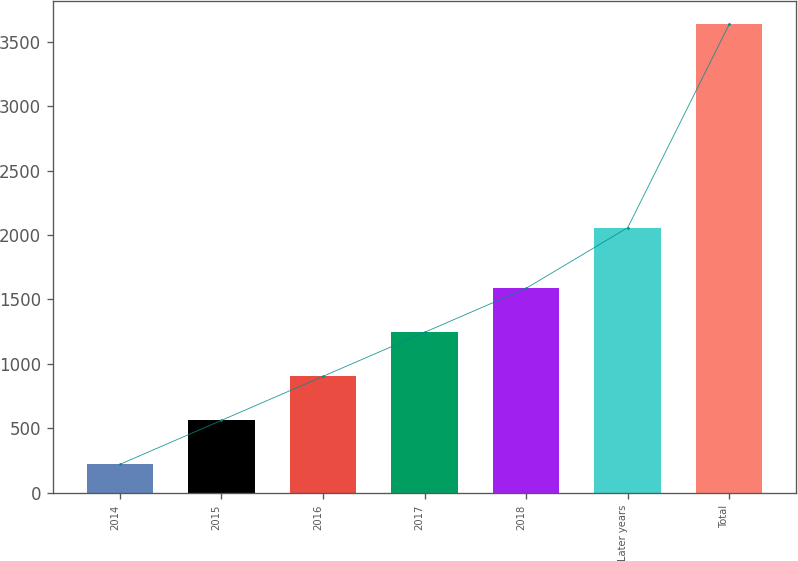Convert chart. <chart><loc_0><loc_0><loc_500><loc_500><bar_chart><fcel>2014<fcel>2015<fcel>2016<fcel>2017<fcel>2018<fcel>Later years<fcel>Total<nl><fcel>221.3<fcel>562.66<fcel>904.02<fcel>1245.38<fcel>1586.74<fcel>2056.9<fcel>3634.9<nl></chart> 